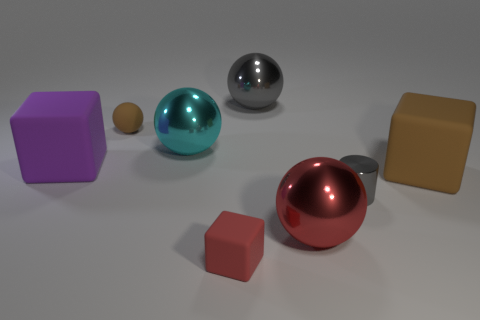Subtract all cyan metallic spheres. How many spheres are left? 3 Subtract all brown balls. How many balls are left? 3 Subtract 1 cylinders. How many cylinders are left? 0 Subtract all blocks. How many objects are left? 5 Subtract all purple balls. How many purple blocks are left? 1 Add 2 gray metal blocks. How many objects exist? 10 Subtract 0 purple spheres. How many objects are left? 8 Subtract all blue cylinders. Subtract all yellow balls. How many cylinders are left? 1 Subtract all tiny matte blocks. Subtract all big red rubber things. How many objects are left? 7 Add 7 cyan objects. How many cyan objects are left? 8 